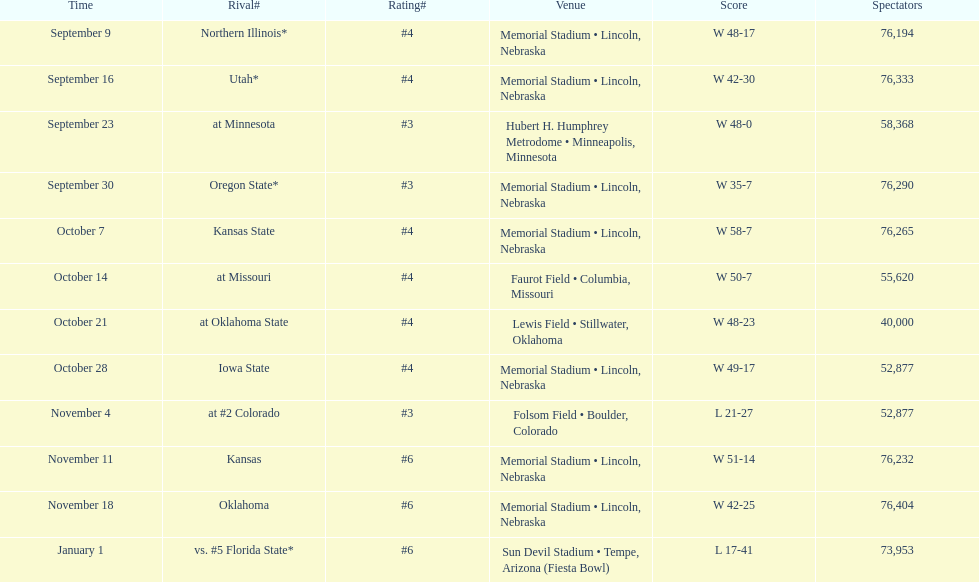On average how many times was w listed as the result? 10. 